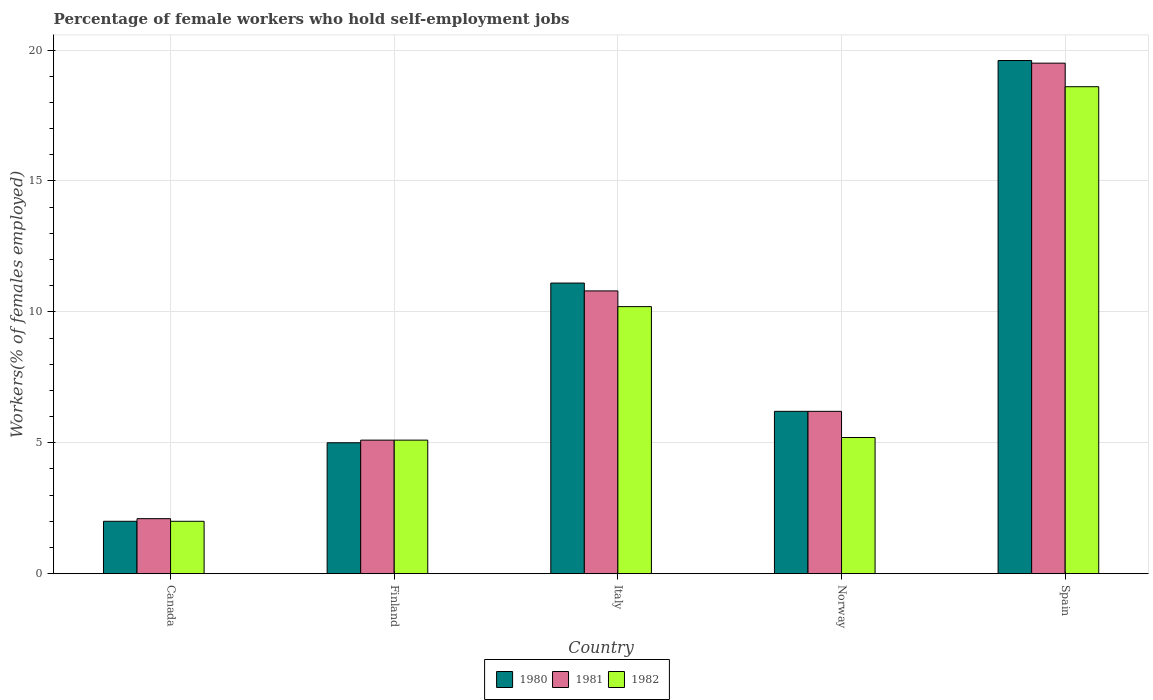How many different coloured bars are there?
Make the answer very short. 3. How many groups of bars are there?
Your answer should be compact. 5. How many bars are there on the 5th tick from the right?
Offer a very short reply. 3. What is the label of the 1st group of bars from the left?
Your answer should be compact. Canada. In how many cases, is the number of bars for a given country not equal to the number of legend labels?
Offer a very short reply. 0. Across all countries, what is the minimum percentage of self-employed female workers in 1981?
Give a very brief answer. 2.1. What is the total percentage of self-employed female workers in 1981 in the graph?
Give a very brief answer. 43.7. What is the difference between the percentage of self-employed female workers in 1981 in Italy and that in Spain?
Offer a very short reply. -8.7. What is the difference between the percentage of self-employed female workers in 1981 in Canada and the percentage of self-employed female workers in 1980 in Finland?
Your answer should be compact. -2.9. What is the average percentage of self-employed female workers in 1981 per country?
Your answer should be compact. 8.74. What is the difference between the percentage of self-employed female workers of/in 1982 and percentage of self-employed female workers of/in 1981 in Norway?
Provide a short and direct response. -1. In how many countries, is the percentage of self-employed female workers in 1980 greater than 14 %?
Offer a very short reply. 1. What is the ratio of the percentage of self-employed female workers in 1980 in Finland to that in Norway?
Give a very brief answer. 0.81. Is the difference between the percentage of self-employed female workers in 1982 in Norway and Spain greater than the difference between the percentage of self-employed female workers in 1981 in Norway and Spain?
Your answer should be very brief. No. What is the difference between the highest and the second highest percentage of self-employed female workers in 1980?
Ensure brevity in your answer.  -8.5. What is the difference between the highest and the lowest percentage of self-employed female workers in 1982?
Your answer should be very brief. 16.6. In how many countries, is the percentage of self-employed female workers in 1980 greater than the average percentage of self-employed female workers in 1980 taken over all countries?
Give a very brief answer. 2. What does the 3rd bar from the left in Spain represents?
Make the answer very short. 1982. How many countries are there in the graph?
Keep it short and to the point. 5. Are the values on the major ticks of Y-axis written in scientific E-notation?
Provide a short and direct response. No. Does the graph contain any zero values?
Ensure brevity in your answer.  No. Does the graph contain grids?
Make the answer very short. Yes. Where does the legend appear in the graph?
Your answer should be compact. Bottom center. How many legend labels are there?
Offer a terse response. 3. What is the title of the graph?
Offer a very short reply. Percentage of female workers who hold self-employment jobs. What is the label or title of the X-axis?
Provide a short and direct response. Country. What is the label or title of the Y-axis?
Your answer should be compact. Workers(% of females employed). What is the Workers(% of females employed) in 1981 in Canada?
Your response must be concise. 2.1. What is the Workers(% of females employed) of 1982 in Canada?
Your answer should be very brief. 2. What is the Workers(% of females employed) in 1981 in Finland?
Ensure brevity in your answer.  5.1. What is the Workers(% of females employed) in 1982 in Finland?
Give a very brief answer. 5.1. What is the Workers(% of females employed) of 1980 in Italy?
Ensure brevity in your answer.  11.1. What is the Workers(% of females employed) of 1981 in Italy?
Offer a terse response. 10.8. What is the Workers(% of females employed) of 1982 in Italy?
Provide a succinct answer. 10.2. What is the Workers(% of females employed) of 1980 in Norway?
Give a very brief answer. 6.2. What is the Workers(% of females employed) of 1981 in Norway?
Give a very brief answer. 6.2. What is the Workers(% of females employed) in 1982 in Norway?
Offer a very short reply. 5.2. What is the Workers(% of females employed) of 1980 in Spain?
Make the answer very short. 19.6. What is the Workers(% of females employed) in 1981 in Spain?
Provide a short and direct response. 19.5. What is the Workers(% of females employed) in 1982 in Spain?
Provide a short and direct response. 18.6. Across all countries, what is the maximum Workers(% of females employed) in 1980?
Your answer should be compact. 19.6. Across all countries, what is the maximum Workers(% of females employed) of 1982?
Your answer should be very brief. 18.6. Across all countries, what is the minimum Workers(% of females employed) in 1980?
Offer a very short reply. 2. Across all countries, what is the minimum Workers(% of females employed) of 1981?
Your response must be concise. 2.1. What is the total Workers(% of females employed) of 1980 in the graph?
Your answer should be very brief. 43.9. What is the total Workers(% of females employed) of 1981 in the graph?
Offer a terse response. 43.7. What is the total Workers(% of females employed) in 1982 in the graph?
Your response must be concise. 41.1. What is the difference between the Workers(% of females employed) of 1981 in Canada and that in Finland?
Ensure brevity in your answer.  -3. What is the difference between the Workers(% of females employed) of 1980 in Canada and that in Italy?
Keep it short and to the point. -9.1. What is the difference between the Workers(% of females employed) in 1981 in Canada and that in Italy?
Offer a terse response. -8.7. What is the difference between the Workers(% of females employed) in 1981 in Canada and that in Norway?
Offer a very short reply. -4.1. What is the difference between the Workers(% of females employed) of 1982 in Canada and that in Norway?
Your response must be concise. -3.2. What is the difference between the Workers(% of females employed) of 1980 in Canada and that in Spain?
Keep it short and to the point. -17.6. What is the difference between the Workers(% of females employed) in 1981 in Canada and that in Spain?
Offer a terse response. -17.4. What is the difference between the Workers(% of females employed) of 1982 in Canada and that in Spain?
Give a very brief answer. -16.6. What is the difference between the Workers(% of females employed) in 1980 in Finland and that in Spain?
Provide a short and direct response. -14.6. What is the difference between the Workers(% of females employed) in 1981 in Finland and that in Spain?
Offer a very short reply. -14.4. What is the difference between the Workers(% of females employed) in 1982 in Finland and that in Spain?
Give a very brief answer. -13.5. What is the difference between the Workers(% of females employed) of 1982 in Italy and that in Norway?
Your answer should be compact. 5. What is the difference between the Workers(% of females employed) in 1980 in Italy and that in Spain?
Make the answer very short. -8.5. What is the difference between the Workers(% of females employed) of 1981 in Italy and that in Spain?
Offer a very short reply. -8.7. What is the difference between the Workers(% of females employed) of 1980 in Norway and that in Spain?
Provide a succinct answer. -13.4. What is the difference between the Workers(% of females employed) in 1981 in Norway and that in Spain?
Provide a succinct answer. -13.3. What is the difference between the Workers(% of females employed) in 1980 in Canada and the Workers(% of females employed) in 1981 in Finland?
Give a very brief answer. -3.1. What is the difference between the Workers(% of females employed) of 1980 in Canada and the Workers(% of females employed) of 1982 in Finland?
Provide a succinct answer. -3.1. What is the difference between the Workers(% of females employed) of 1981 in Canada and the Workers(% of females employed) of 1982 in Finland?
Offer a terse response. -3. What is the difference between the Workers(% of females employed) of 1980 in Canada and the Workers(% of females employed) of 1981 in Italy?
Your response must be concise. -8.8. What is the difference between the Workers(% of females employed) of 1980 in Canada and the Workers(% of females employed) of 1982 in Italy?
Keep it short and to the point. -8.2. What is the difference between the Workers(% of females employed) of 1981 in Canada and the Workers(% of females employed) of 1982 in Italy?
Provide a succinct answer. -8.1. What is the difference between the Workers(% of females employed) of 1980 in Canada and the Workers(% of females employed) of 1982 in Norway?
Ensure brevity in your answer.  -3.2. What is the difference between the Workers(% of females employed) in 1980 in Canada and the Workers(% of females employed) in 1981 in Spain?
Give a very brief answer. -17.5. What is the difference between the Workers(% of females employed) of 1980 in Canada and the Workers(% of females employed) of 1982 in Spain?
Offer a terse response. -16.6. What is the difference between the Workers(% of females employed) of 1981 in Canada and the Workers(% of females employed) of 1982 in Spain?
Give a very brief answer. -16.5. What is the difference between the Workers(% of females employed) in 1981 in Finland and the Workers(% of females employed) in 1982 in Italy?
Your answer should be compact. -5.1. What is the difference between the Workers(% of females employed) in 1980 in Finland and the Workers(% of females employed) in 1982 in Norway?
Offer a very short reply. -0.2. What is the difference between the Workers(% of females employed) in 1980 in Finland and the Workers(% of females employed) in 1982 in Spain?
Keep it short and to the point. -13.6. What is the difference between the Workers(% of females employed) of 1980 in Italy and the Workers(% of females employed) of 1982 in Norway?
Ensure brevity in your answer.  5.9. What is the difference between the Workers(% of females employed) in 1981 in Italy and the Workers(% of females employed) in 1982 in Spain?
Offer a very short reply. -7.8. What is the average Workers(% of females employed) in 1980 per country?
Provide a short and direct response. 8.78. What is the average Workers(% of females employed) of 1981 per country?
Your response must be concise. 8.74. What is the average Workers(% of females employed) of 1982 per country?
Offer a terse response. 8.22. What is the difference between the Workers(% of females employed) in 1980 and Workers(% of females employed) in 1981 in Canada?
Ensure brevity in your answer.  -0.1. What is the difference between the Workers(% of females employed) of 1981 and Workers(% of females employed) of 1982 in Canada?
Keep it short and to the point. 0.1. What is the difference between the Workers(% of females employed) of 1981 and Workers(% of females employed) of 1982 in Finland?
Give a very brief answer. 0. What is the difference between the Workers(% of females employed) of 1980 and Workers(% of females employed) of 1981 in Italy?
Give a very brief answer. 0.3. What is the difference between the Workers(% of females employed) in 1980 and Workers(% of females employed) in 1981 in Norway?
Make the answer very short. 0. What is the difference between the Workers(% of females employed) of 1980 and Workers(% of females employed) of 1982 in Spain?
Give a very brief answer. 1. What is the ratio of the Workers(% of females employed) of 1980 in Canada to that in Finland?
Offer a terse response. 0.4. What is the ratio of the Workers(% of females employed) of 1981 in Canada to that in Finland?
Your response must be concise. 0.41. What is the ratio of the Workers(% of females employed) in 1982 in Canada to that in Finland?
Keep it short and to the point. 0.39. What is the ratio of the Workers(% of females employed) in 1980 in Canada to that in Italy?
Offer a very short reply. 0.18. What is the ratio of the Workers(% of females employed) in 1981 in Canada to that in Italy?
Ensure brevity in your answer.  0.19. What is the ratio of the Workers(% of females employed) in 1982 in Canada to that in Italy?
Make the answer very short. 0.2. What is the ratio of the Workers(% of females employed) in 1980 in Canada to that in Norway?
Keep it short and to the point. 0.32. What is the ratio of the Workers(% of females employed) in 1981 in Canada to that in Norway?
Give a very brief answer. 0.34. What is the ratio of the Workers(% of females employed) of 1982 in Canada to that in Norway?
Offer a very short reply. 0.38. What is the ratio of the Workers(% of females employed) of 1980 in Canada to that in Spain?
Your answer should be very brief. 0.1. What is the ratio of the Workers(% of females employed) in 1981 in Canada to that in Spain?
Give a very brief answer. 0.11. What is the ratio of the Workers(% of females employed) in 1982 in Canada to that in Spain?
Keep it short and to the point. 0.11. What is the ratio of the Workers(% of females employed) of 1980 in Finland to that in Italy?
Provide a succinct answer. 0.45. What is the ratio of the Workers(% of females employed) of 1981 in Finland to that in Italy?
Provide a short and direct response. 0.47. What is the ratio of the Workers(% of females employed) in 1982 in Finland to that in Italy?
Provide a succinct answer. 0.5. What is the ratio of the Workers(% of females employed) of 1980 in Finland to that in Norway?
Keep it short and to the point. 0.81. What is the ratio of the Workers(% of females employed) in 1981 in Finland to that in Norway?
Keep it short and to the point. 0.82. What is the ratio of the Workers(% of females employed) in 1982 in Finland to that in Norway?
Offer a very short reply. 0.98. What is the ratio of the Workers(% of females employed) in 1980 in Finland to that in Spain?
Your response must be concise. 0.26. What is the ratio of the Workers(% of females employed) of 1981 in Finland to that in Spain?
Provide a succinct answer. 0.26. What is the ratio of the Workers(% of females employed) in 1982 in Finland to that in Spain?
Offer a terse response. 0.27. What is the ratio of the Workers(% of females employed) of 1980 in Italy to that in Norway?
Provide a short and direct response. 1.79. What is the ratio of the Workers(% of females employed) of 1981 in Italy to that in Norway?
Keep it short and to the point. 1.74. What is the ratio of the Workers(% of females employed) of 1982 in Italy to that in Norway?
Your response must be concise. 1.96. What is the ratio of the Workers(% of females employed) of 1980 in Italy to that in Spain?
Provide a short and direct response. 0.57. What is the ratio of the Workers(% of females employed) in 1981 in Italy to that in Spain?
Give a very brief answer. 0.55. What is the ratio of the Workers(% of females employed) in 1982 in Italy to that in Spain?
Make the answer very short. 0.55. What is the ratio of the Workers(% of females employed) in 1980 in Norway to that in Spain?
Keep it short and to the point. 0.32. What is the ratio of the Workers(% of females employed) of 1981 in Norway to that in Spain?
Your answer should be compact. 0.32. What is the ratio of the Workers(% of females employed) in 1982 in Norway to that in Spain?
Ensure brevity in your answer.  0.28. What is the difference between the highest and the second highest Workers(% of females employed) in 1980?
Offer a terse response. 8.5. What is the difference between the highest and the second highest Workers(% of females employed) in 1981?
Give a very brief answer. 8.7. What is the difference between the highest and the second highest Workers(% of females employed) of 1982?
Your response must be concise. 8.4. What is the difference between the highest and the lowest Workers(% of females employed) of 1980?
Offer a very short reply. 17.6. What is the difference between the highest and the lowest Workers(% of females employed) of 1981?
Your response must be concise. 17.4. What is the difference between the highest and the lowest Workers(% of females employed) of 1982?
Ensure brevity in your answer.  16.6. 